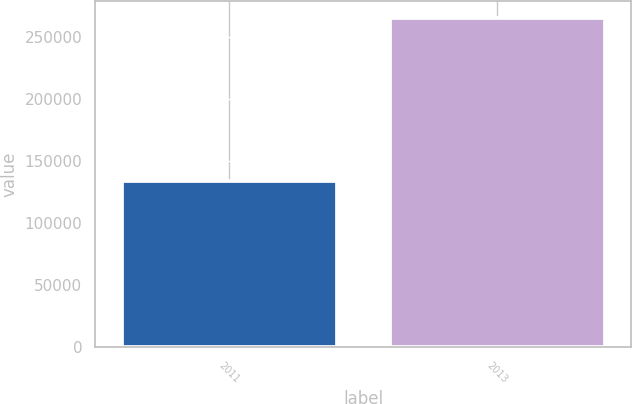Convert chart to OTSL. <chart><loc_0><loc_0><loc_500><loc_500><bar_chart><fcel>2011<fcel>2013<nl><fcel>133775<fcel>265583<nl></chart> 